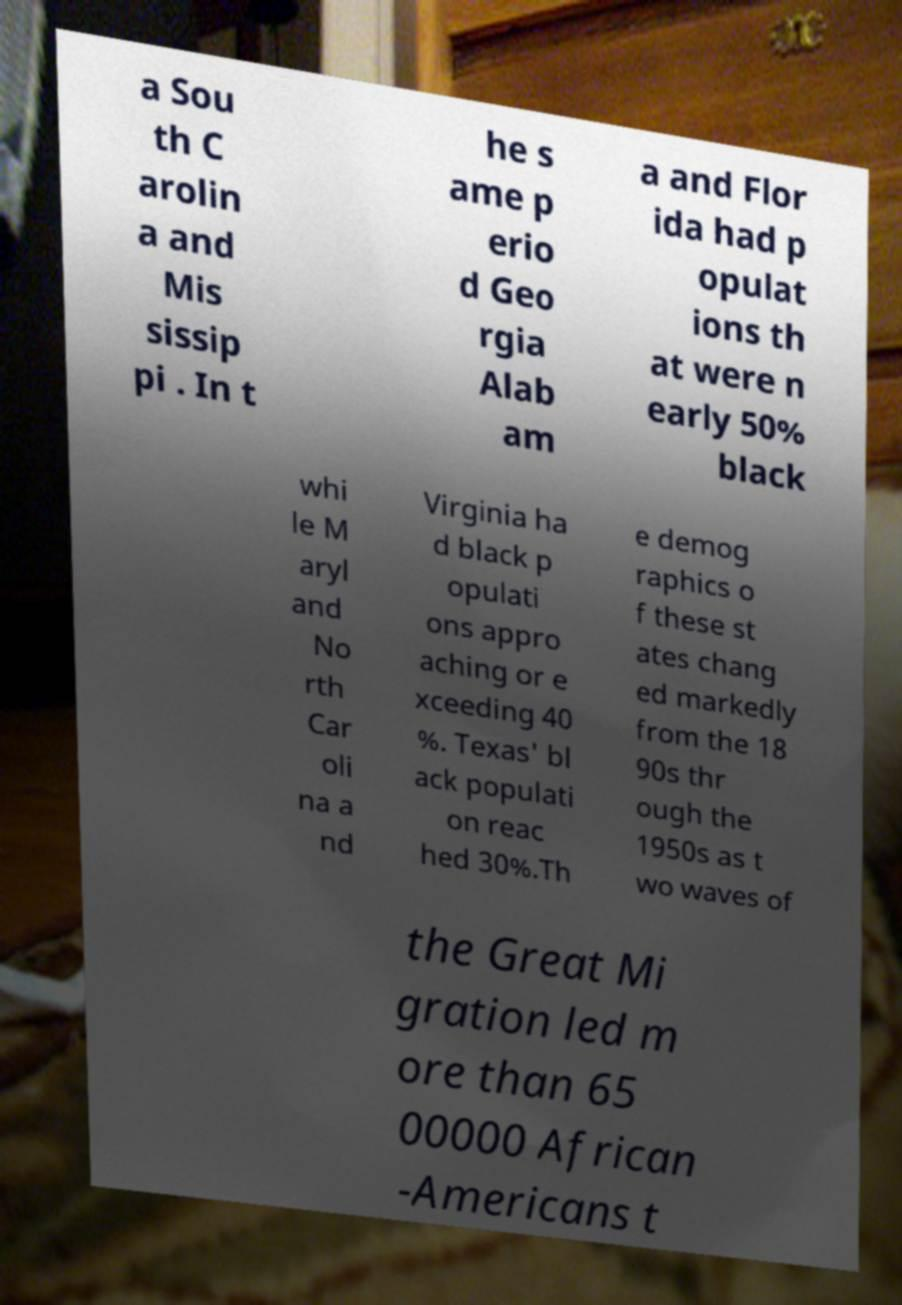For documentation purposes, I need the text within this image transcribed. Could you provide that? a Sou th C arolin a and Mis sissip pi . In t he s ame p erio d Geo rgia Alab am a and Flor ida had p opulat ions th at were n early 50% black whi le M aryl and No rth Car oli na a nd Virginia ha d black p opulati ons appro aching or e xceeding 40 %. Texas' bl ack populati on reac hed 30%.Th e demog raphics o f these st ates chang ed markedly from the 18 90s thr ough the 1950s as t wo waves of the Great Mi gration led m ore than 65 00000 African -Americans t 